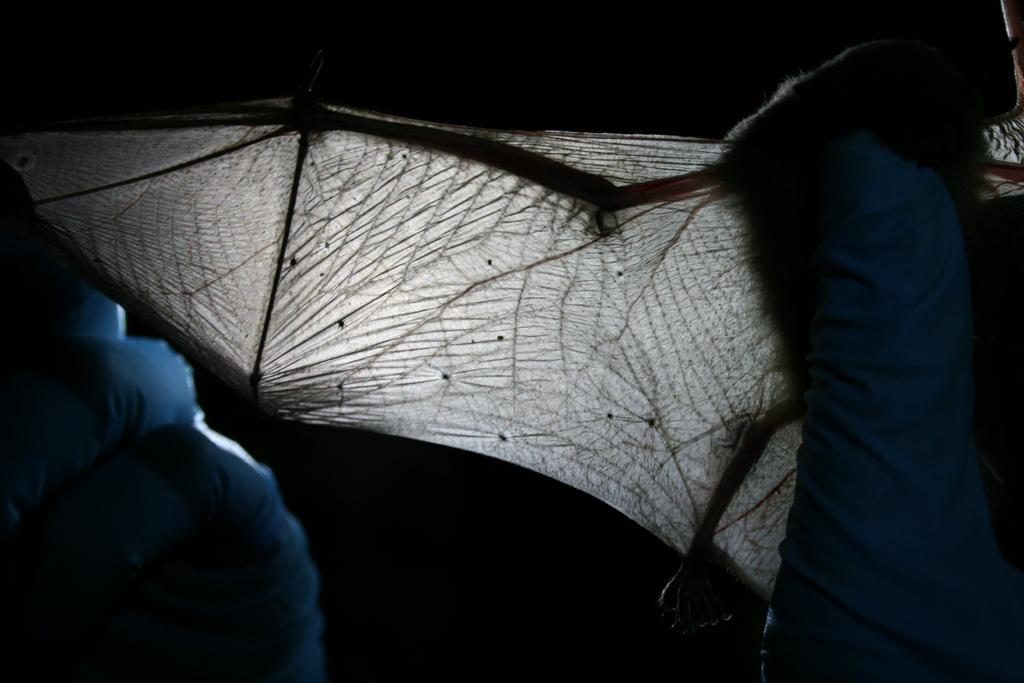What can be seen in the image? There is a person in the image. What is the person wearing on their hands? The person is wearing blue gloves. What is the person holding in their hands? The person is holding an object in their hands. What type of bottle is the person holding in the image? There is no bottle present in the image; the person is holding an object, but it is not specified as a bottle. 